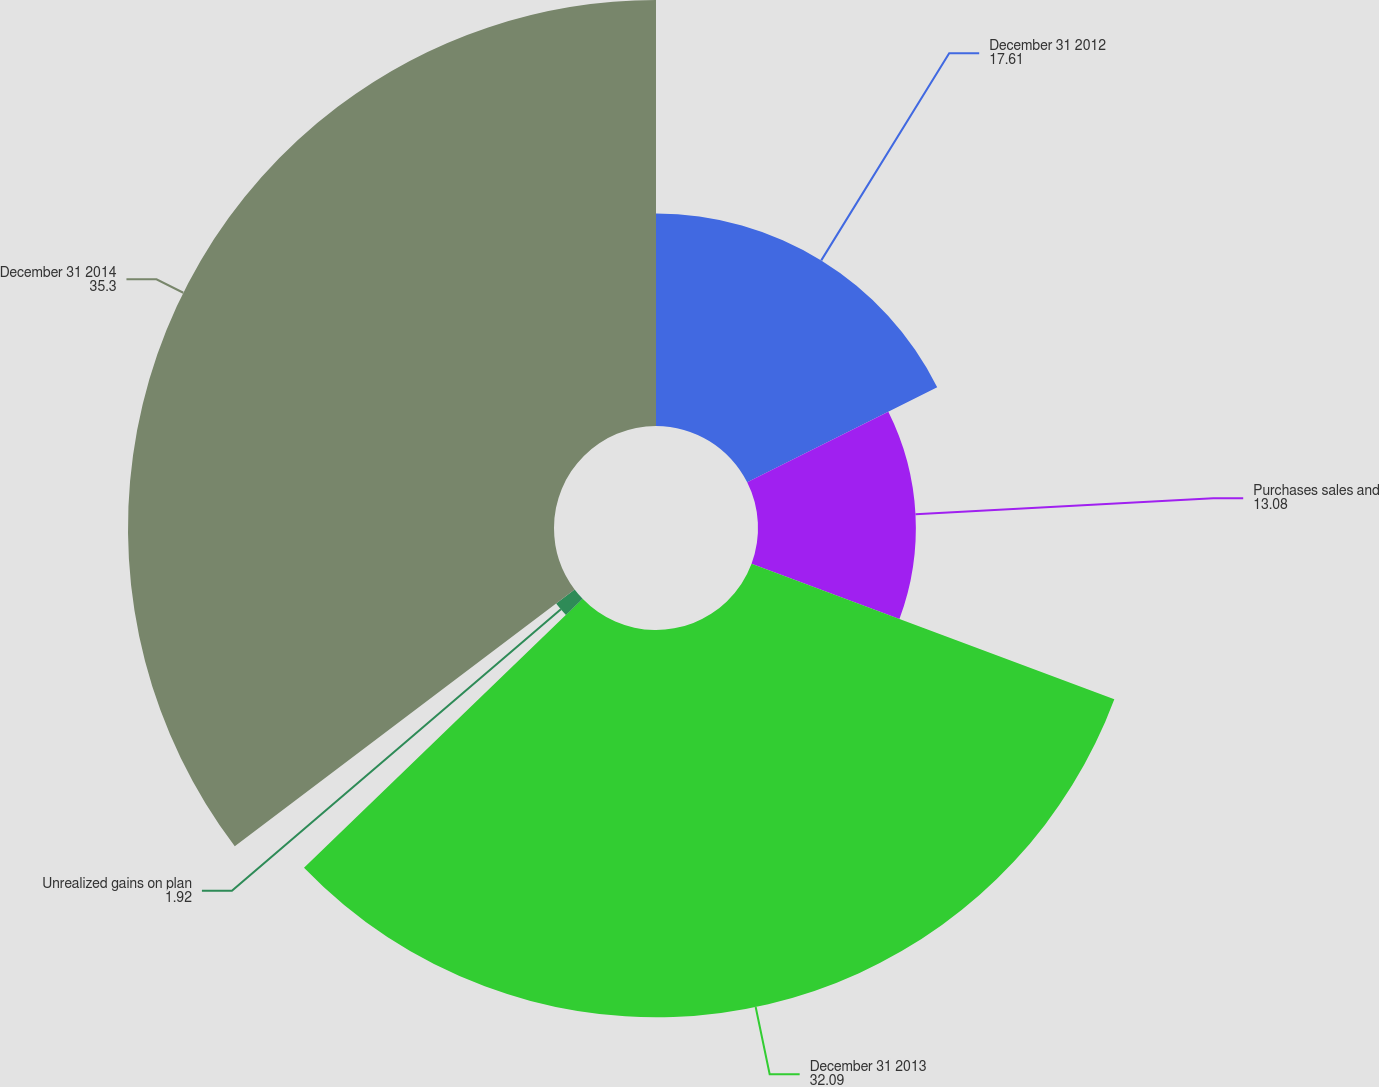Convert chart. <chart><loc_0><loc_0><loc_500><loc_500><pie_chart><fcel>December 31 2012<fcel>Purchases sales and<fcel>December 31 2013<fcel>Unrealized gains on plan<fcel>December 31 2014<nl><fcel>17.61%<fcel>13.08%<fcel>32.09%<fcel>1.92%<fcel>35.3%<nl></chart> 